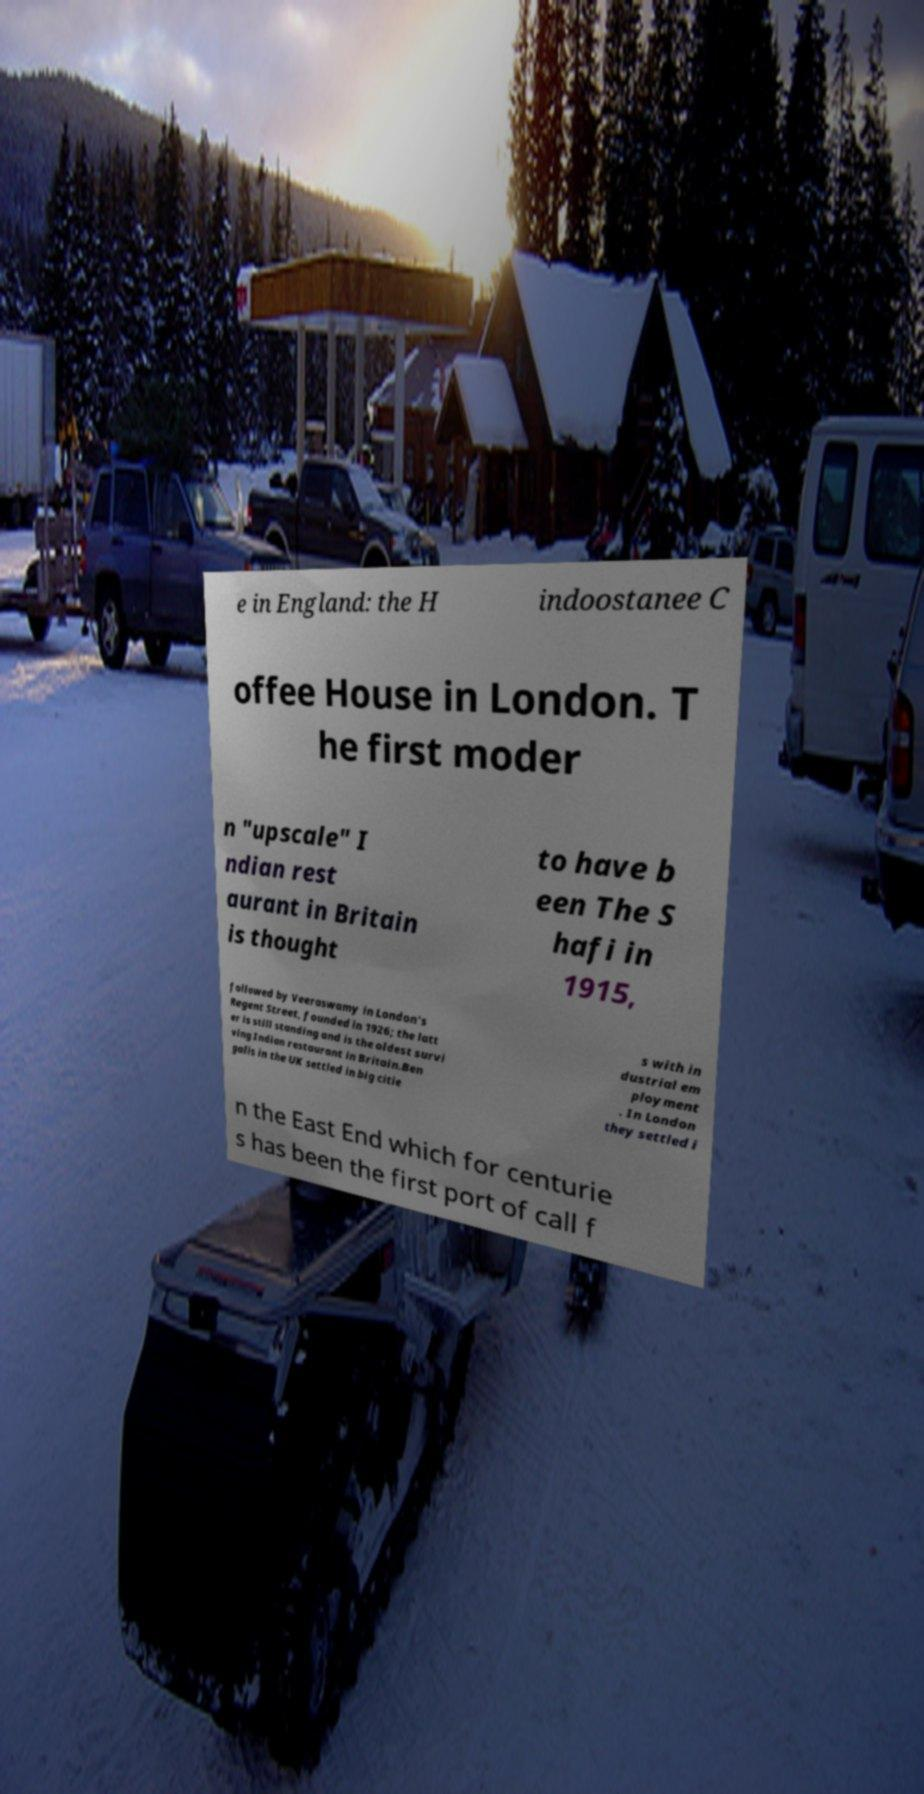For documentation purposes, I need the text within this image transcribed. Could you provide that? e in England: the H indoostanee C offee House in London. T he first moder n "upscale" I ndian rest aurant in Britain is thought to have b een The S hafi in 1915, followed by Veeraswamy in London's Regent Street, founded in 1926; the latt er is still standing and is the oldest survi ving Indian restaurant in Britain.Ben galis in the UK settled in big citie s with in dustrial em ployment . In London they settled i n the East End which for centurie s has been the first port of call f 